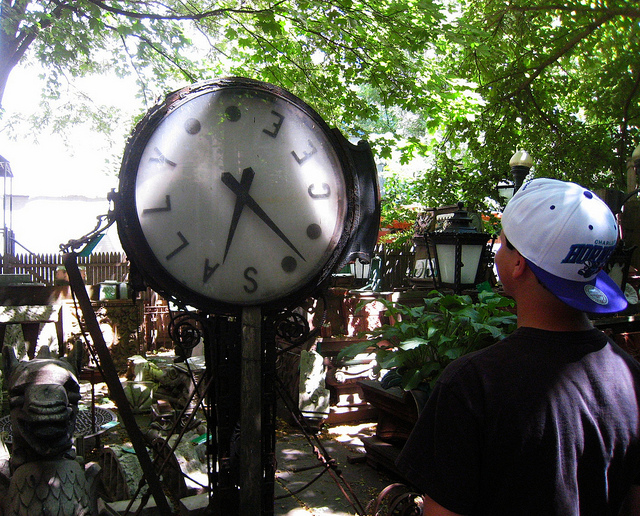Please transcribe the text information in this image. E E S L L A C Y 